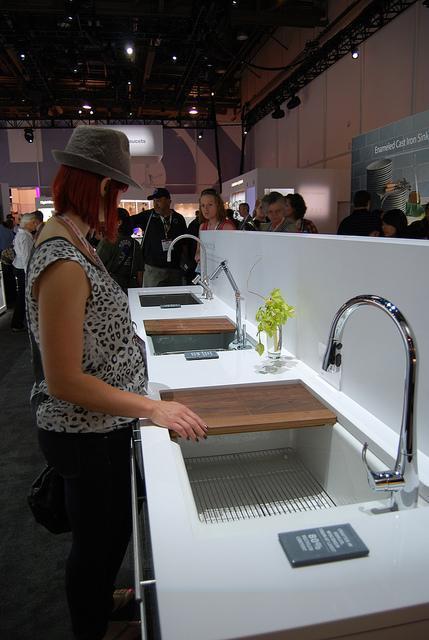If this person wanted to wash their hands where would they have to go?
Select the accurate answer and provide justification: `Answer: choice
Rationale: srationale.`
Options: Here, gas station, bathroom, kitchen. Answer: bathroom.
Rationale: A woman stands at a display in a large showroom area. 